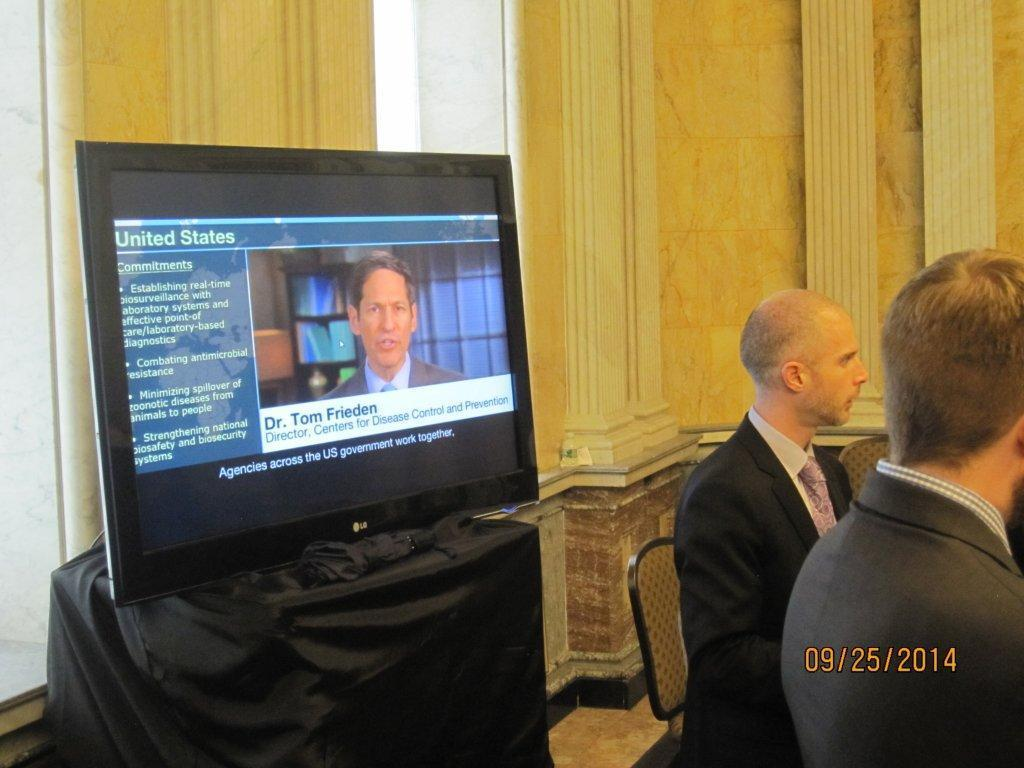<image>
Relay a brief, clear account of the picture shown. The date that's printed on this image is "09/25/2014." 